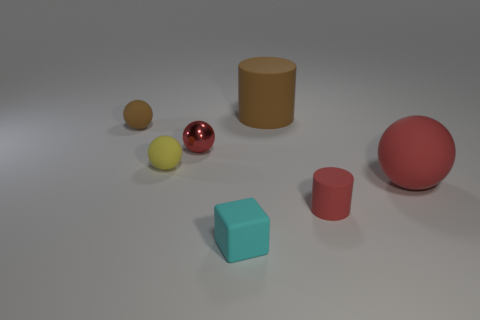What is the color of the tiny thing to the right of the tiny cyan cube?
Your answer should be very brief. Red. The brown cylinder that is made of the same material as the small brown object is what size?
Provide a short and direct response. Large. There is a tiny matte object behind the small yellow object; what number of matte objects are behind it?
Your answer should be very brief. 1. There is a big brown cylinder; what number of balls are left of it?
Offer a terse response. 3. What is the color of the rubber cylinder that is behind the red sphere on the left side of the red rubber thing that is left of the big rubber ball?
Offer a very short reply. Brown. There is a matte ball to the right of the yellow rubber object; is it the same color as the small matte sphere that is in front of the red shiny thing?
Offer a terse response. No. There is a small object that is on the right side of the brown matte object to the right of the matte cube; what is its shape?
Offer a very short reply. Cylinder. Are there any red things that have the same size as the brown sphere?
Provide a succinct answer. Yes. How many tiny brown rubber objects are the same shape as the large red object?
Ensure brevity in your answer.  1. Is the number of shiny balls in front of the matte block the same as the number of tiny cyan things on the right side of the red metal object?
Ensure brevity in your answer.  No. 